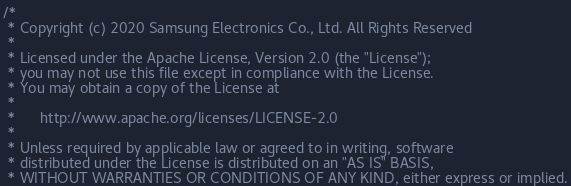Convert code to text. <code><loc_0><loc_0><loc_500><loc_500><_C++_>/*
 * Copyright (c) 2020 Samsung Electronics Co., Ltd. All Rights Reserved
 *
 * Licensed under the Apache License, Version 2.0 (the "License");
 * you may not use this file except in compliance with the License.
 * You may obtain a copy of the License at
 *
 *      http://www.apache.org/licenses/LICENSE-2.0
 *
 * Unless required by applicable law or agreed to in writing, software
 * distributed under the License is distributed on an "AS IS" BASIS,
 * WITHOUT WARRANTIES OR CONDITIONS OF ANY KIND, either express or implied.</code> 